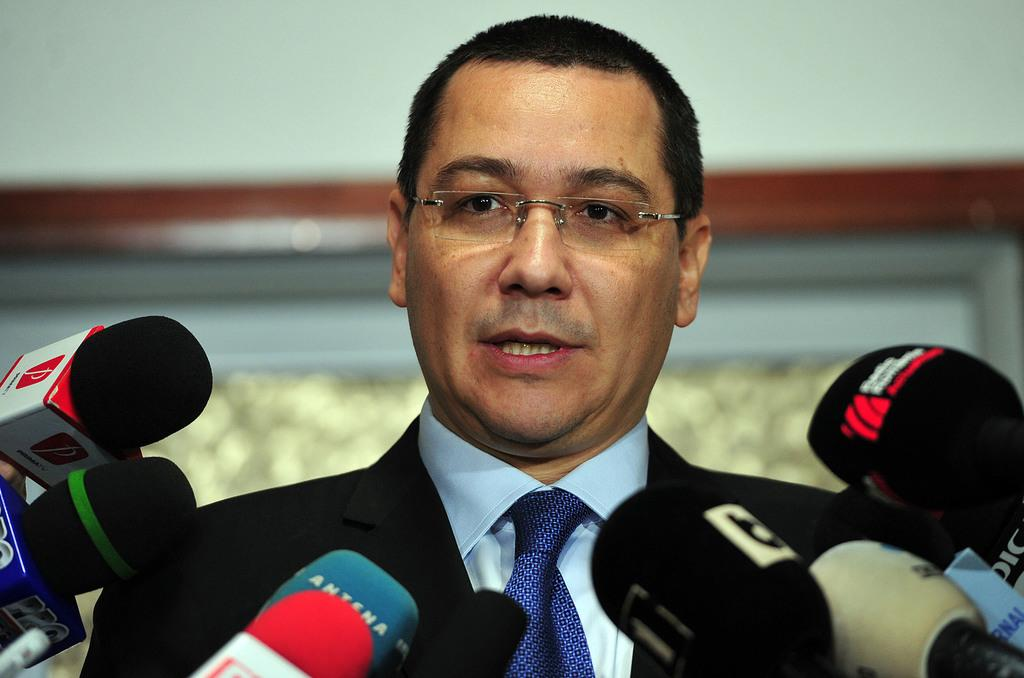Who is present in the image? There is a man in the image. What is the man wearing? The man is wearing a suit. What is the man doing in the image? The man is talking. What accessory is the man wearing? The man is wearing glasses. What objects can be seen at the bottom of the image? There are microphones at the bottom of the image. How would you describe the background of the image? The background of the image is blurry. What color is visible in the image? There is a white color visible in the image. What type of truck is parked in front of the prison in the image? There is no truck or prison present in the image; it features a man talking while wearing a suit, glasses, and holding a microphone. What advice does the man's uncle give him in the image? There is no mention of an uncle or any advice-giving in the image. 